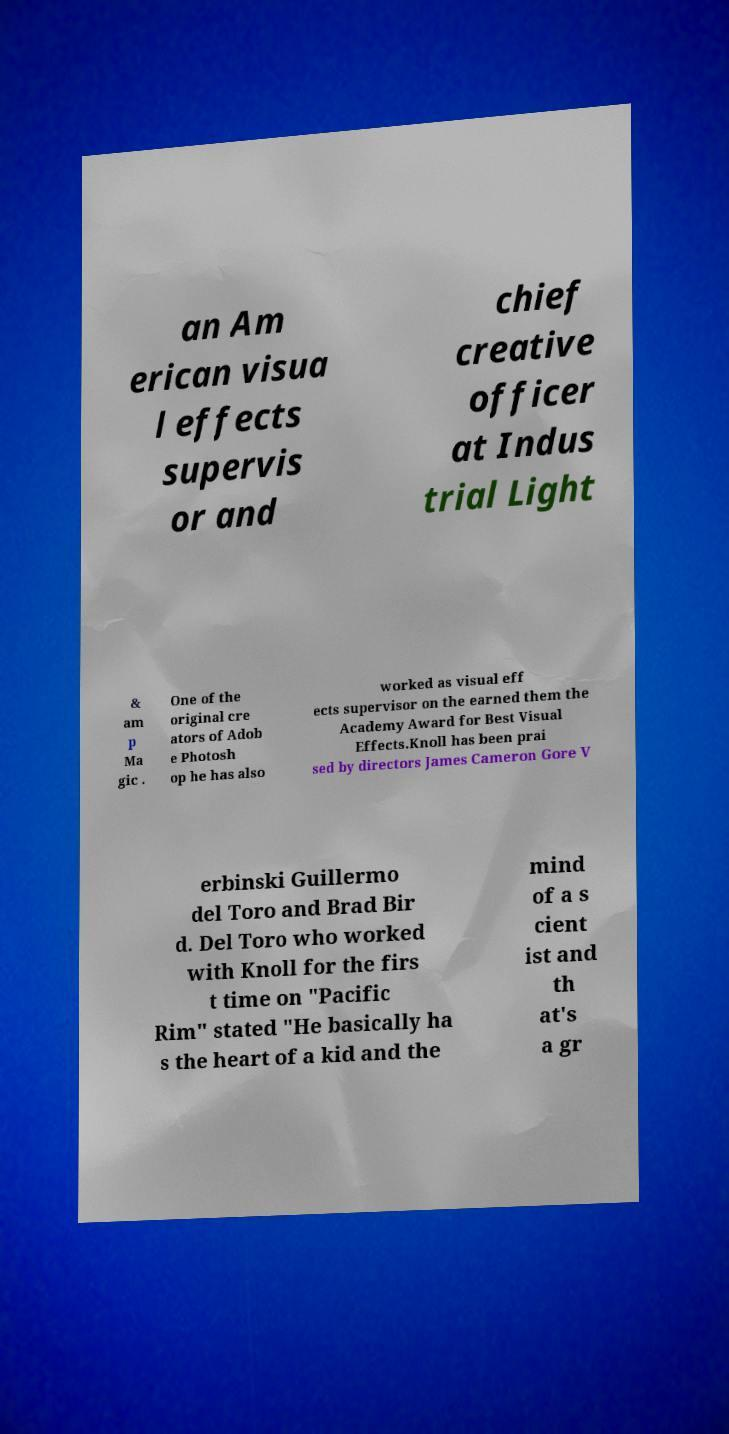I need the written content from this picture converted into text. Can you do that? an Am erican visua l effects supervis or and chief creative officer at Indus trial Light & am p Ma gic . One of the original cre ators of Adob e Photosh op he has also worked as visual eff ects supervisor on the earned them the Academy Award for Best Visual Effects.Knoll has been prai sed by directors James Cameron Gore V erbinski Guillermo del Toro and Brad Bir d. Del Toro who worked with Knoll for the firs t time on "Pacific Rim" stated "He basically ha s the heart of a kid and the mind of a s cient ist and th at's a gr 